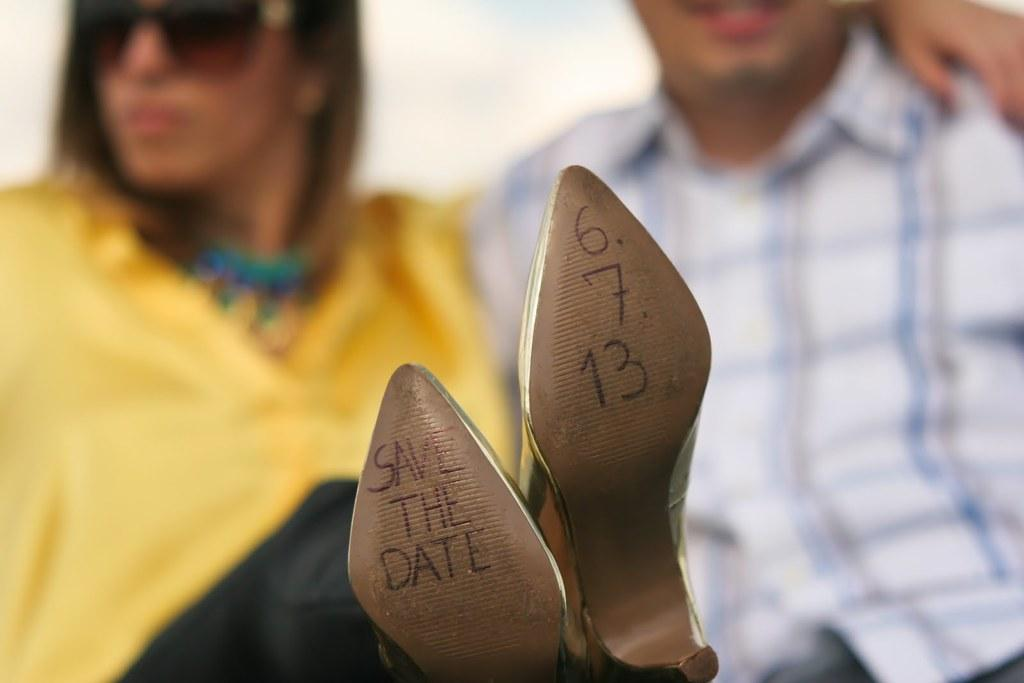What is written on the footwear in the image? There are texts and digits written on a footwear in the image. Can you describe the people in the background of the image? Unfortunately, the provided facts do not give any information about the people in the background. What type of footwear is featured in the image? The facts only mention that there are texts and digits written on a footwear, but they do not specify the type of footwear. Can you see any cobwebs in the image? There is no mention of cobwebs in the provided facts, and therefore we cannot determine if any are present in the image. 